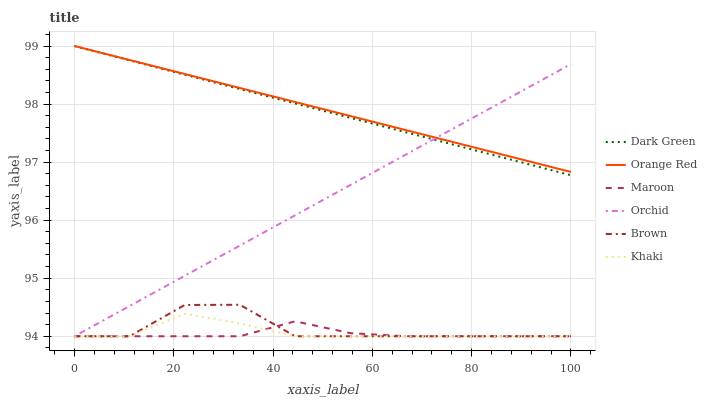Does Maroon have the minimum area under the curve?
Answer yes or no. Yes. Does Orange Red have the maximum area under the curve?
Answer yes or no. Yes. Does Khaki have the minimum area under the curve?
Answer yes or no. No. Does Khaki have the maximum area under the curve?
Answer yes or no. No. Is Orchid the smoothest?
Answer yes or no. Yes. Is Brown the roughest?
Answer yes or no. Yes. Is Khaki the smoothest?
Answer yes or no. No. Is Khaki the roughest?
Answer yes or no. No. Does Dark Green have the lowest value?
Answer yes or no. No. Does Orange Red have the highest value?
Answer yes or no. Yes. Does Khaki have the highest value?
Answer yes or no. No. Is Brown less than Orange Red?
Answer yes or no. Yes. Is Dark Green greater than Khaki?
Answer yes or no. Yes. Does Maroon intersect Brown?
Answer yes or no. Yes. Is Maroon less than Brown?
Answer yes or no. No. Is Maroon greater than Brown?
Answer yes or no. No. Does Brown intersect Orange Red?
Answer yes or no. No. 